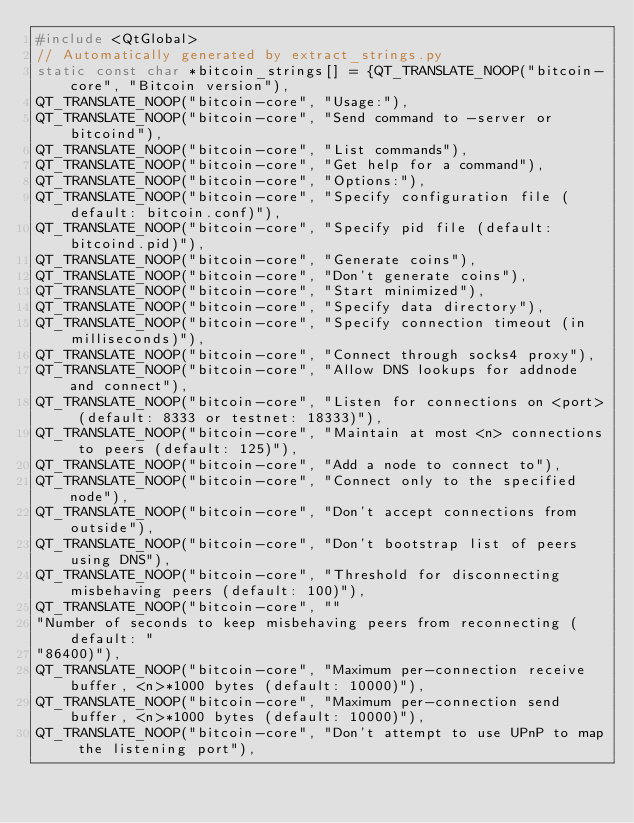<code> <loc_0><loc_0><loc_500><loc_500><_C++_>#include <QtGlobal>
// Automatically generated by extract_strings.py
static const char *bitcoin_strings[] = {QT_TRANSLATE_NOOP("bitcoin-core", "Bitcoin version"),
QT_TRANSLATE_NOOP("bitcoin-core", "Usage:"),
QT_TRANSLATE_NOOP("bitcoin-core", "Send command to -server or bitcoind"),
QT_TRANSLATE_NOOP("bitcoin-core", "List commands"),
QT_TRANSLATE_NOOP("bitcoin-core", "Get help for a command"),
QT_TRANSLATE_NOOP("bitcoin-core", "Options:"),
QT_TRANSLATE_NOOP("bitcoin-core", "Specify configuration file (default: bitcoin.conf)"),
QT_TRANSLATE_NOOP("bitcoin-core", "Specify pid file (default: bitcoind.pid)"),
QT_TRANSLATE_NOOP("bitcoin-core", "Generate coins"),
QT_TRANSLATE_NOOP("bitcoin-core", "Don't generate coins"),
QT_TRANSLATE_NOOP("bitcoin-core", "Start minimized"),
QT_TRANSLATE_NOOP("bitcoin-core", "Specify data directory"),
QT_TRANSLATE_NOOP("bitcoin-core", "Specify connection timeout (in milliseconds)"),
QT_TRANSLATE_NOOP("bitcoin-core", "Connect through socks4 proxy"),
QT_TRANSLATE_NOOP("bitcoin-core", "Allow DNS lookups for addnode and connect"),
QT_TRANSLATE_NOOP("bitcoin-core", "Listen for connections on <port> (default: 8333 or testnet: 18333)"),
QT_TRANSLATE_NOOP("bitcoin-core", "Maintain at most <n> connections to peers (default: 125)"),
QT_TRANSLATE_NOOP("bitcoin-core", "Add a node to connect to"),
QT_TRANSLATE_NOOP("bitcoin-core", "Connect only to the specified node"),
QT_TRANSLATE_NOOP("bitcoin-core", "Don't accept connections from outside"),
QT_TRANSLATE_NOOP("bitcoin-core", "Don't bootstrap list of peers using DNS"),
QT_TRANSLATE_NOOP("bitcoin-core", "Threshold for disconnecting misbehaving peers (default: 100)"),
QT_TRANSLATE_NOOP("bitcoin-core", ""
"Number of seconds to keep misbehaving peers from reconnecting (default: "
"86400)"),
QT_TRANSLATE_NOOP("bitcoin-core", "Maximum per-connection receive buffer, <n>*1000 bytes (default: 10000)"),
QT_TRANSLATE_NOOP("bitcoin-core", "Maximum per-connection send buffer, <n>*1000 bytes (default: 10000)"),
QT_TRANSLATE_NOOP("bitcoin-core", "Don't attempt to use UPnP to map the listening port"),</code> 